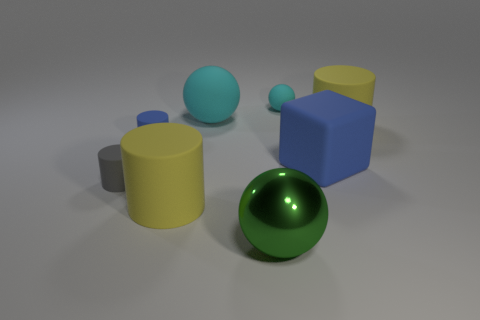Is there any other thing that has the same material as the big green thing?
Ensure brevity in your answer.  No. How many objects are either rubber things to the right of the tiny blue matte cylinder or blue matte things right of the tiny blue matte object?
Offer a very short reply. 5. Does the metallic ball have the same size as the rubber cube?
Your response must be concise. Yes. How many blocks are large metallic things or small cyan objects?
Make the answer very short. 0. How many big objects are right of the metallic object and to the left of the metallic sphere?
Your answer should be very brief. 0. There is a gray rubber object; does it have the same size as the blue rubber thing to the left of the large blue object?
Keep it short and to the point. Yes. There is a ball in front of the large cylinder that is behind the gray rubber cylinder; are there any small cyan rubber spheres in front of it?
Provide a short and direct response. No. There is a big ball in front of the yellow matte cylinder behind the blue cylinder; what is its material?
Offer a terse response. Metal. The big object that is in front of the small gray rubber thing and to the right of the large cyan rubber thing is made of what material?
Your answer should be very brief. Metal. Are there any green things of the same shape as the big cyan thing?
Offer a very short reply. Yes. 